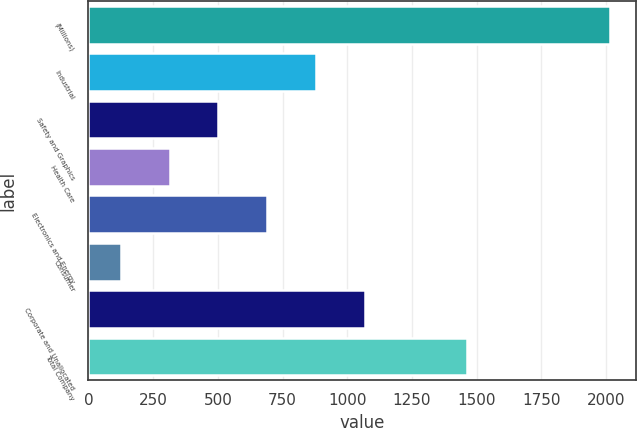Convert chart. <chart><loc_0><loc_0><loc_500><loc_500><bar_chart><fcel>(Millions)<fcel>Industrial<fcel>Safety and Graphics<fcel>Health Care<fcel>Electronics and Energy<fcel>Consumer<fcel>Corporate and Unallocated<fcel>Total Company<nl><fcel>2015<fcel>880.4<fcel>502.2<fcel>313.1<fcel>691.3<fcel>124<fcel>1069.5<fcel>1461<nl></chart> 